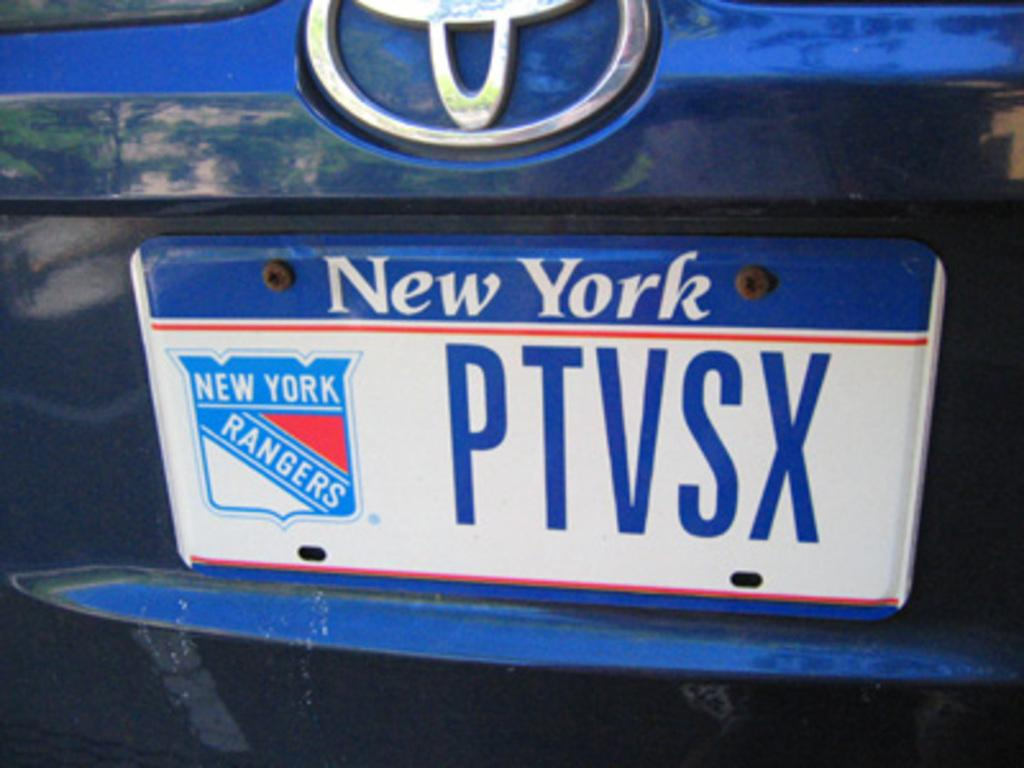Provide a one-sentence caption for the provided image. The driver of this car is a New York Rangers fan. 